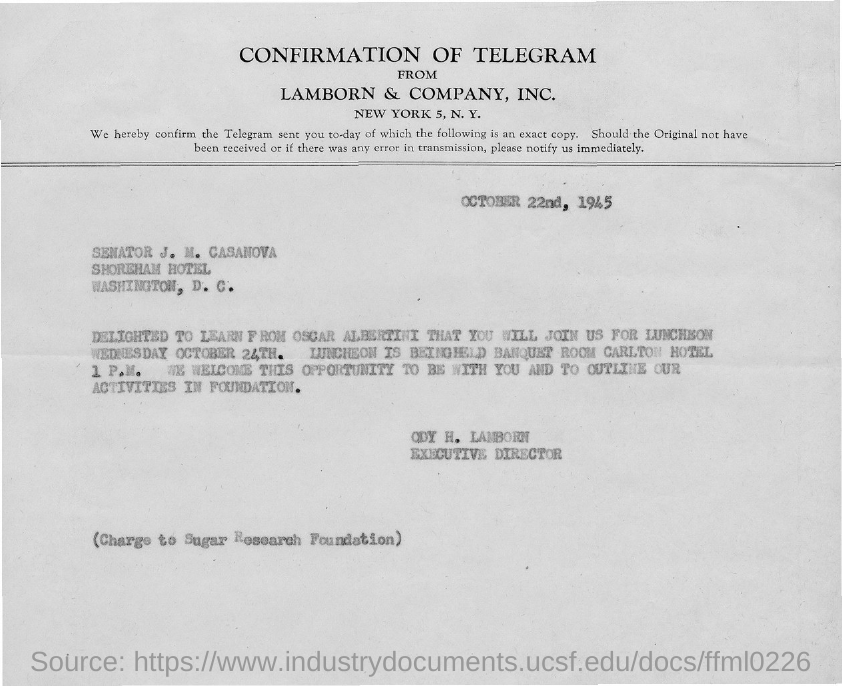Give some essential details in this illustration. The luncheon is scheduled for 1 P.M... The date on the document is October 22nd, 1945. I am delighted to learn from Oscar Albertini. 